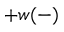Convert formula to latex. <formula><loc_0><loc_0><loc_500><loc_500>+ w ( - )</formula> 